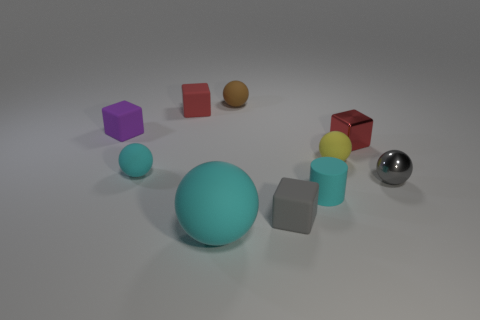Subtract all red balls. Subtract all purple cylinders. How many balls are left? 5 Subtract all cylinders. How many objects are left? 9 Add 7 tiny red blocks. How many tiny red blocks are left? 9 Add 7 small brown metallic cubes. How many small brown metallic cubes exist? 7 Subtract 0 purple spheres. How many objects are left? 10 Subtract all green rubber cylinders. Subtract all red matte cubes. How many objects are left? 9 